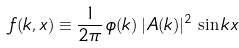Convert formula to latex. <formula><loc_0><loc_0><loc_500><loc_500>f ( k , x ) \equiv \frac { 1 } { 2 \pi } \, \phi ( k ) \, | A ( k ) | ^ { 2 } \, \sin k x</formula> 